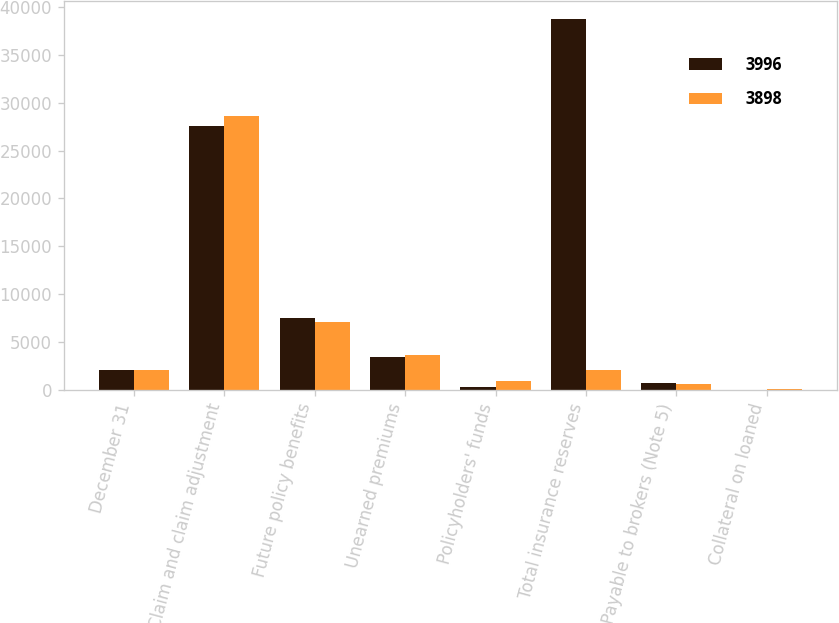Convert chart. <chart><loc_0><loc_0><loc_500><loc_500><stacked_bar_chart><ecel><fcel>December 31<fcel>Claim and claim adjustment<fcel>Future policy benefits<fcel>Unearned premiums<fcel>Policyholders' funds<fcel>Total insurance reserves<fcel>Payable to brokers (Note 5)<fcel>Collateral on loaned<nl><fcel>3996<fcel>2008<fcel>27593<fcel>7529<fcel>3405<fcel>243<fcel>38770<fcel>679<fcel>6<nl><fcel>3898<fcel>2007<fcel>28588<fcel>7106<fcel>3597<fcel>930<fcel>2008<fcel>580<fcel>63<nl></chart> 